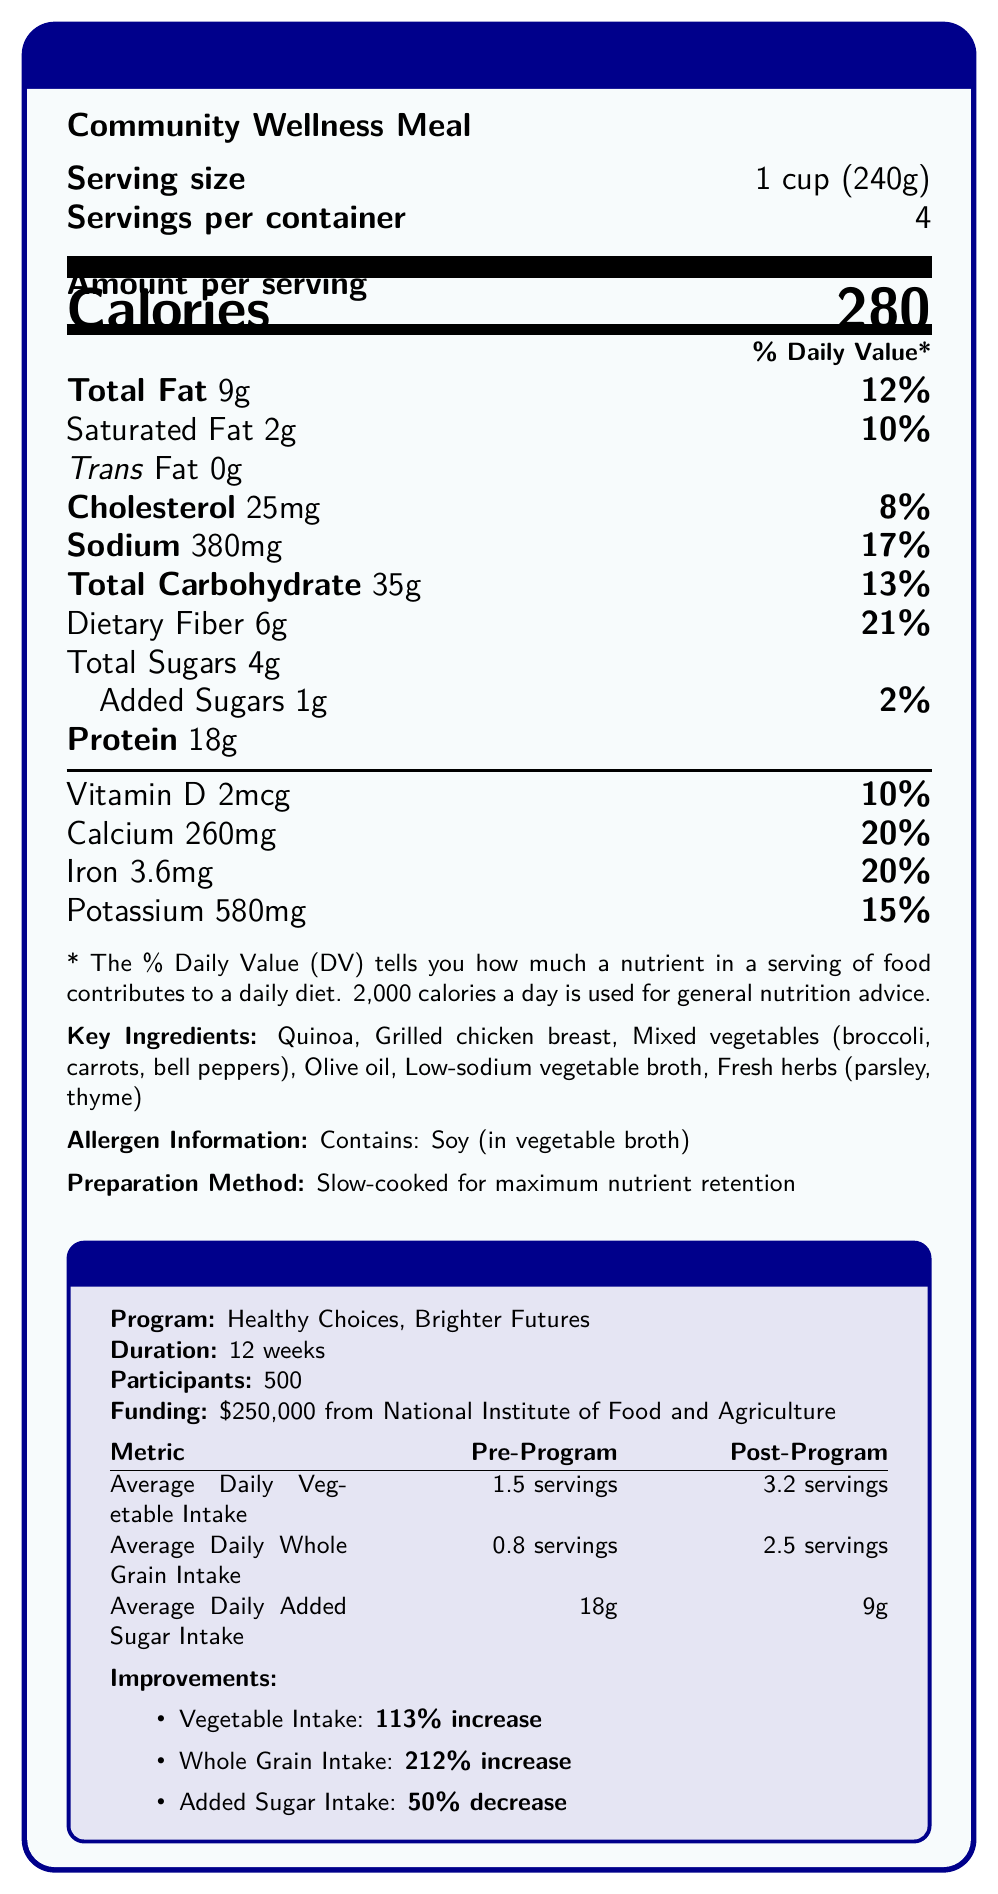what is the serving size of the Community Wellness Meal? The document states that the serving size is "1 cup (240g)".
Answer: 1 cup (240g) how many calories are in one serving? The document lists "Calories: 280" for one serving.
Answer: 280 how much dietary fiber is in one serving? The table shows that dietary fiber amount per serving is 6g.
Answer: 6g what is the percentage increase in average daily vegetable intake after the program? The document mentions a "113% increase" in average daily vegetable intake.
Answer: 113% how many participants were involved in the nutrition education program? The document specifies that there were 500 participants in the program.
Answer: 500 what is the added sugars' daily value percentage per serving in the Community Wellness Meal? A. 1% B. 2% C. 4% The document shows that the added sugars in the meal account for 2% of the daily value.
Answer: B how much funding did the nutrition education program receive? A. $100,000 B. $250,000 C. $350,000 D. $500,000 The document states that the funding amount for the nutrition education program was $250,000.
Answer: B which of the following is not an ingredient in the Community Wellness Meal? A. Quinoa B. Olive oil C. Spinach D. Grilled chicken breast The document lists quinoa, olive oil, and grilled chicken breast as ingredients but does not mention spinach.
Answer: C is the preparation method for the Community Wellness Meal slow-cooked? The preparation method is described as "Slow-cooked for maximum nutrient retention".
Answer: Yes summarize the main idea of the document. The document describes the nutritional content of the Community Wellness Meal, its ingredients, allergens, and preparation, and also details the significant improvements in dietary habits achieved through a 12-week nutrition education program funded by the National Institute of Food and Agriculture.
Answer: The document provides the nutrition facts for the Community Wellness Meal, highlights its key ingredients, allergens, and preparation method, and showcases the positive impact of the nutrition education program, "Healthy Choices, Brighter Futures," on the participants' dietary habits. what is the average daily added sugar intake post-program? The document states that the average daily added sugar intake post-program is 9g.
Answer: 9g how many grams of protein are in one serving of the Community Wellness Meal? The document lists the protein content as 18g per serving.
Answer: 18g cannot be determined if the meal is suitable for someone with a nut allergy. The allergen information provided only lists soy and does not mention any information about nuts.
Answer: Cannot be determined what are the vitamin D and calcium percentages of the daily value? The document provides that Vitamin D is 10% and Calcium is 20% of the daily value per serving.
Answer: Vitamin D: 10%, Calcium: 20% compare the pre-program and post-program average daily whole grain intake. The document shows that the average daily whole grain intake increased from 0.8 servings pre-program to 2.5 servings post-program, indicating a positive change.
Answer: Pre-program: 0.8 servings, Post-program: 2.5 servings 